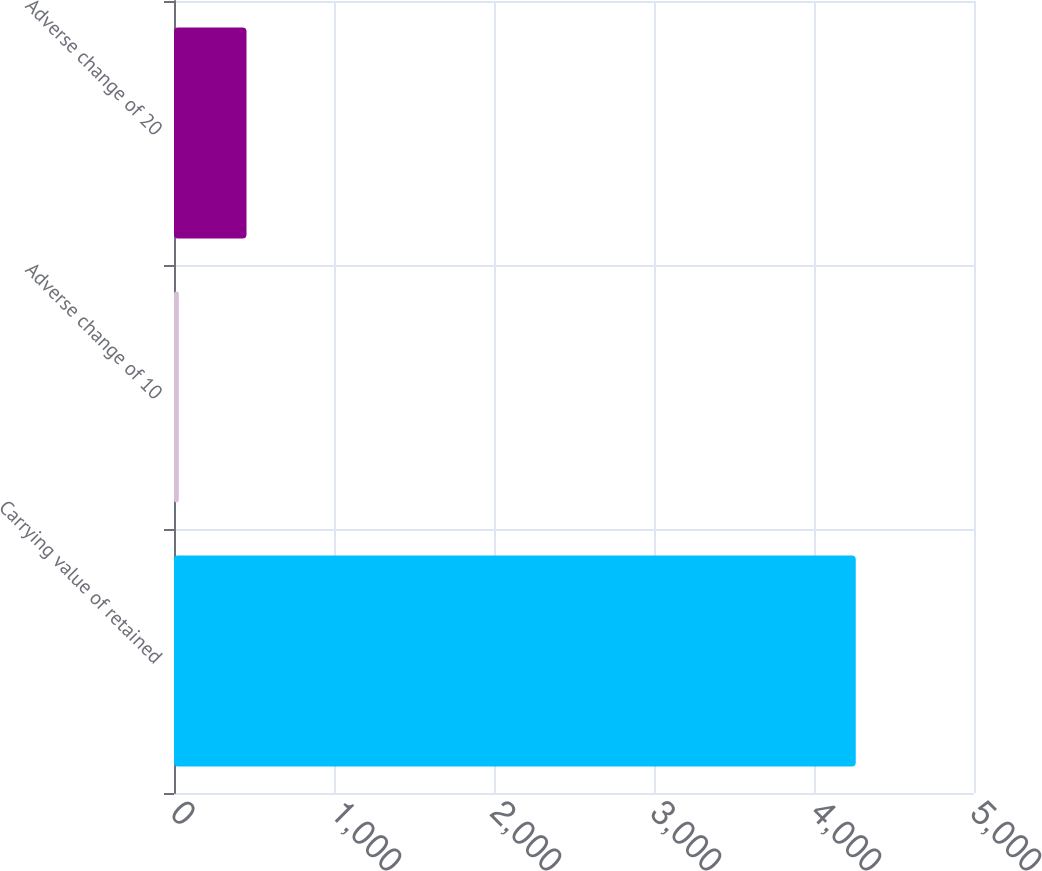<chart> <loc_0><loc_0><loc_500><loc_500><bar_chart><fcel>Carrying value of retained<fcel>Adverse change of 10<fcel>Adverse change of 20<nl><fcel>4261<fcel>30<fcel>453.1<nl></chart> 